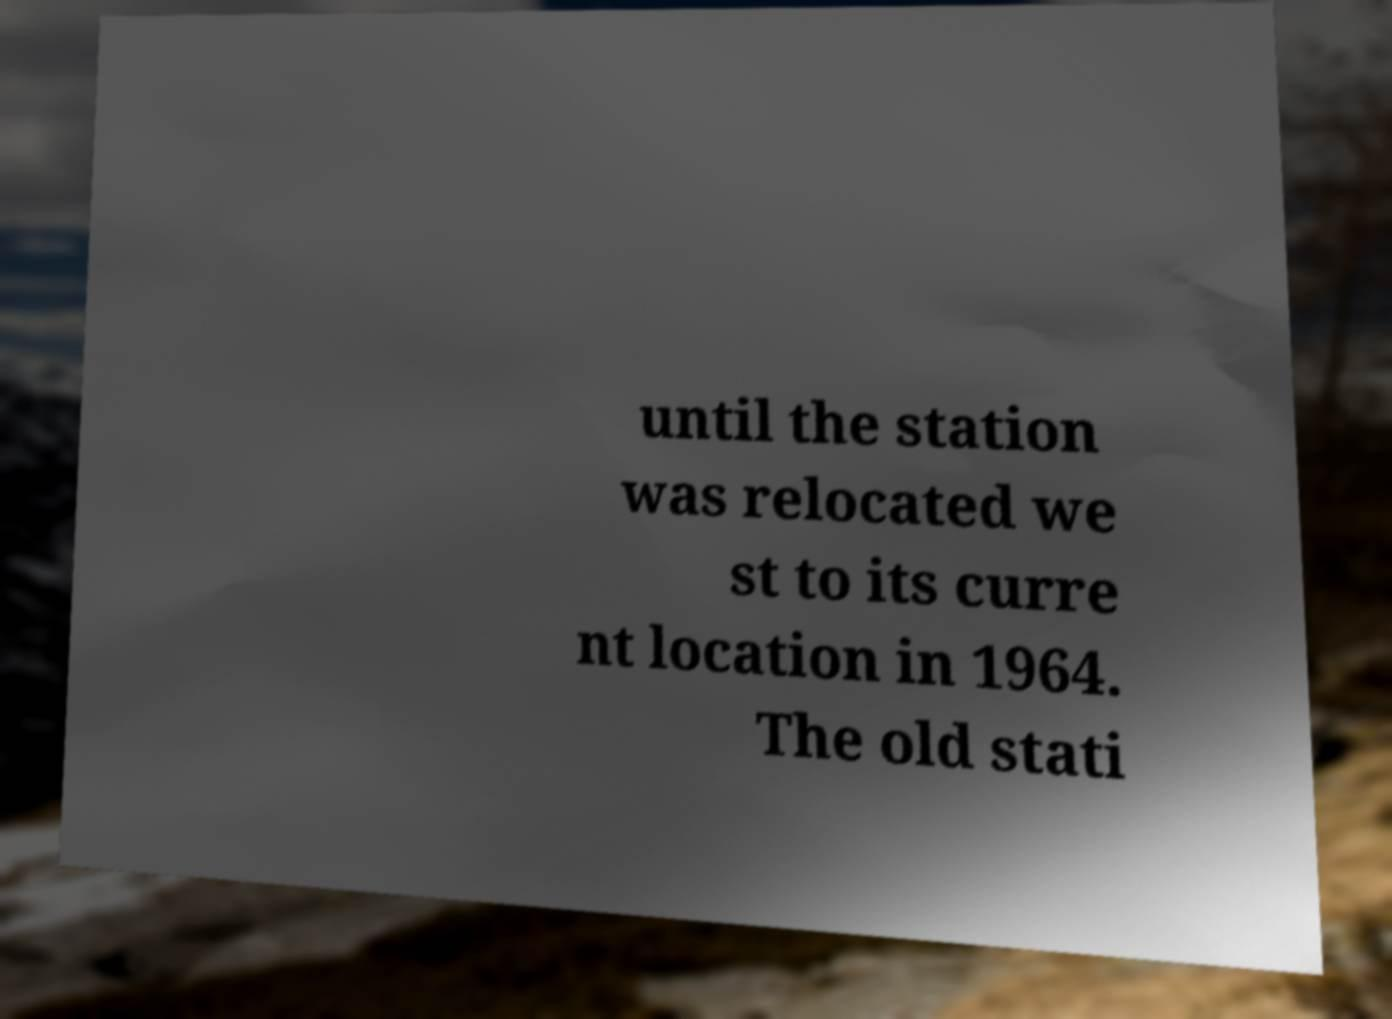I need the written content from this picture converted into text. Can you do that? until the station was relocated we st to its curre nt location in 1964. The old stati 